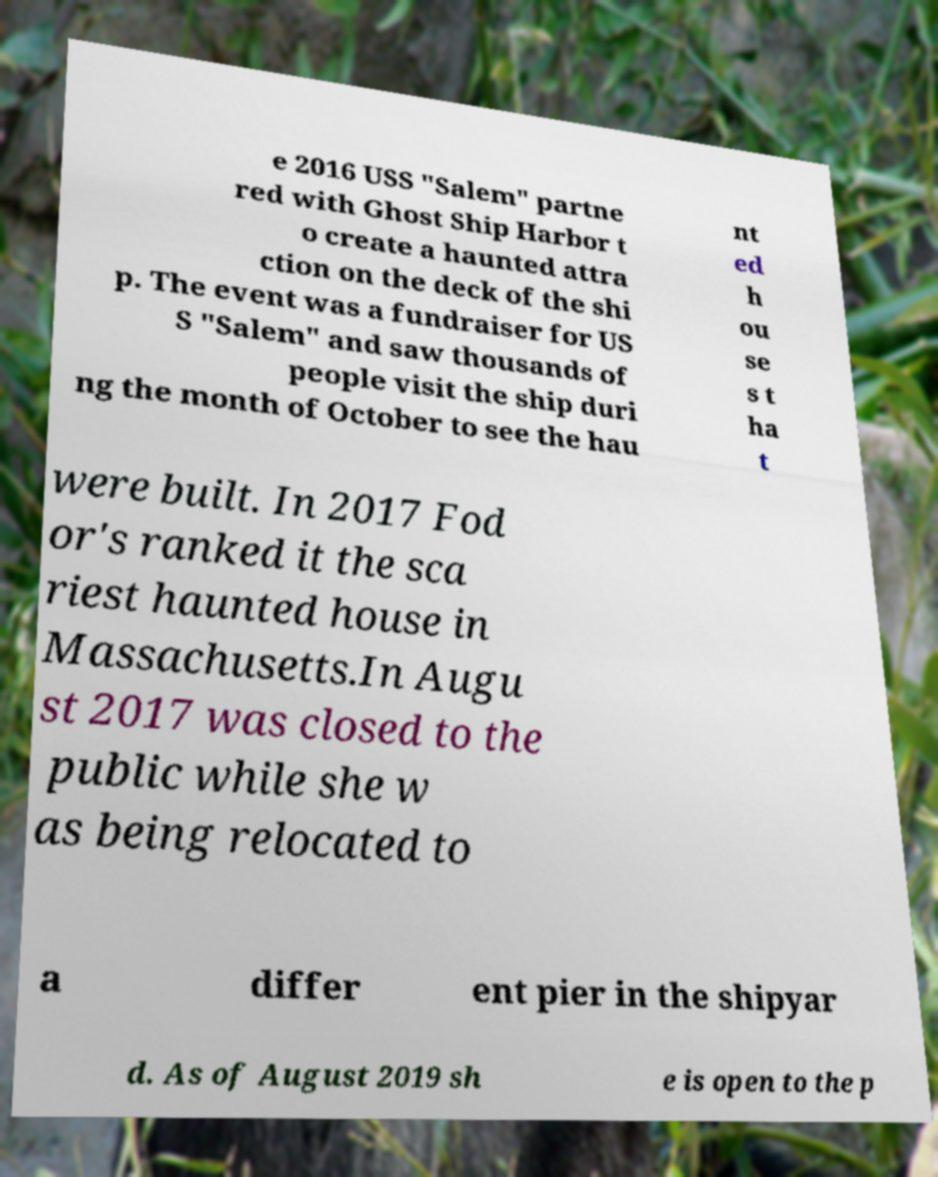I need the written content from this picture converted into text. Can you do that? e 2016 USS "Salem" partne red with Ghost Ship Harbor t o create a haunted attra ction on the deck of the shi p. The event was a fundraiser for US S "Salem" and saw thousands of people visit the ship duri ng the month of October to see the hau nt ed h ou se s t ha t were built. In 2017 Fod or's ranked it the sca riest haunted house in Massachusetts.In Augu st 2017 was closed to the public while she w as being relocated to a differ ent pier in the shipyar d. As of August 2019 sh e is open to the p 